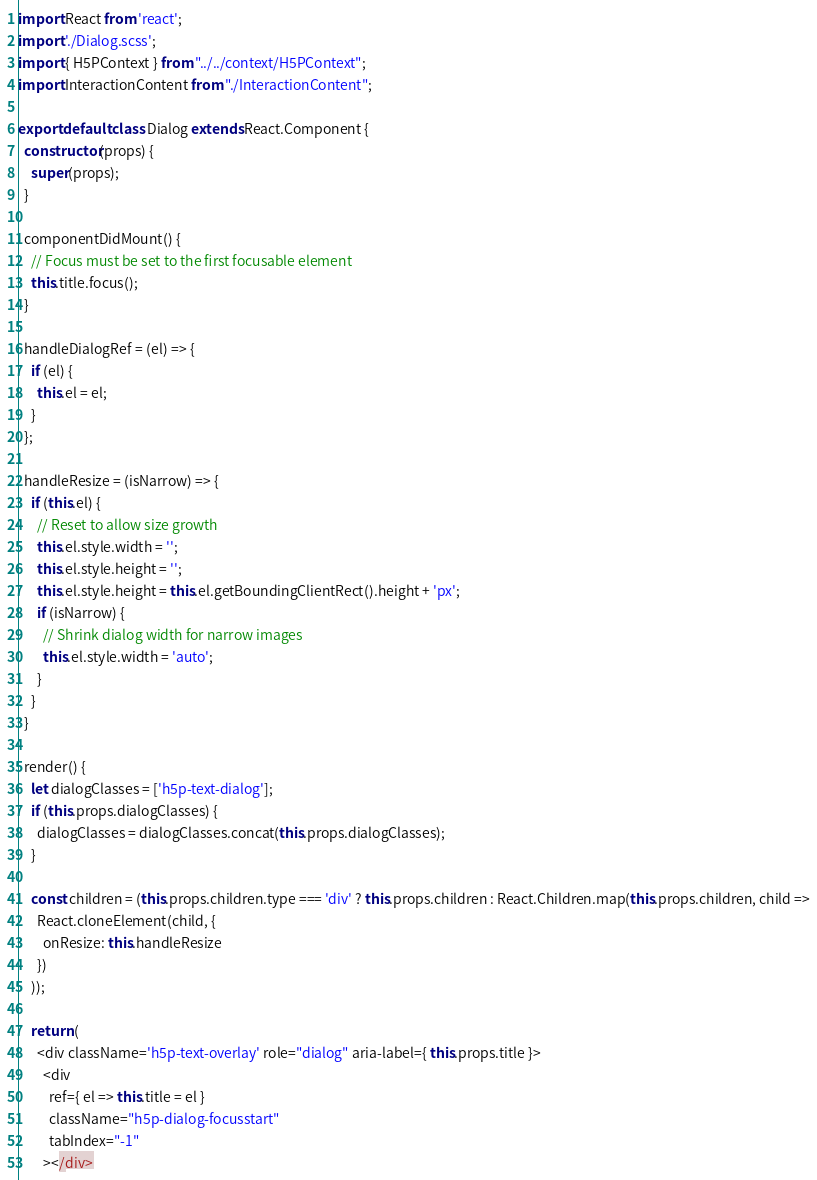<code> <loc_0><loc_0><loc_500><loc_500><_JavaScript_>import React from 'react';
import './Dialog.scss';
import { H5PContext } from "../../context/H5PContext";
import InteractionContent from "./InteractionContent";

export default class Dialog extends React.Component {
  constructor(props) {
    super(props);
  }

  componentDidMount() {
    // Focus must be set to the first focusable element
    this.title.focus();
  }

  handleDialogRef = (el) => {
    if (el) {
      this.el = el;
    }
  };

  handleResize = (isNarrow) => {
    if (this.el) {
      // Reset to allow size growth
      this.el.style.width = '';
      this.el.style.height = '';
      this.el.style.height = this.el.getBoundingClientRect().height + 'px';
      if (isNarrow) {
        // Shrink dialog width for narrow images
        this.el.style.width = 'auto';
      }
    }
  }

  render() {
    let dialogClasses = ['h5p-text-dialog'];
    if (this.props.dialogClasses) {
      dialogClasses = dialogClasses.concat(this.props.dialogClasses);
    }

    const children = (this.props.children.type === 'div' ? this.props.children : React.Children.map(this.props.children, child =>
      React.cloneElement(child, {
        onResize: this.handleResize
      })
    ));

    return (
      <div className='h5p-text-overlay' role="dialog" aria-label={ this.props.title }>
        <div
          ref={ el => this.title = el }
          className="h5p-dialog-focusstart"
          tabIndex="-1"
        ></div></code> 